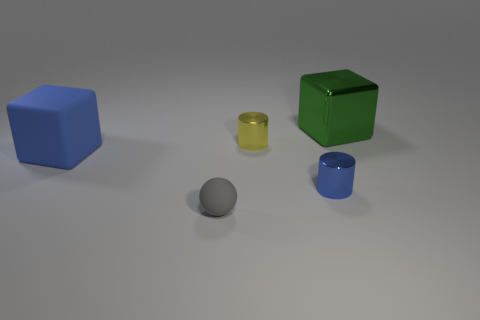Which objects in the image are closest to the large green cube? The large blue cylinder is closest to the large green cube, positioned to its right.  How many objects have a cylindrical shape? There are two objects with a cylindrical shape in the image: one large blue cylinder and one small yellow cylinder. 